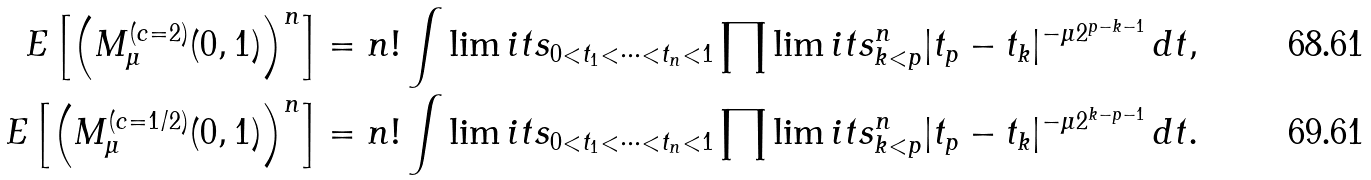<formula> <loc_0><loc_0><loc_500><loc_500>{ E } \left [ \left ( M _ { \mu } ^ { ( c = 2 ) } ( 0 , 1 ) \right ) ^ { n } \right ] & = n ! \int \lim i t s _ { 0 < t _ { 1 } < \cdots < t _ { n } < 1 } \prod \lim i t s _ { k < p } ^ { n } | t _ { p } - t _ { k } | ^ { - \mu 2 ^ { p - k - 1 } } \, d t , \\ { E } \left [ \left ( M _ { \mu } ^ { ( c = 1 / 2 ) } ( 0 , 1 ) \right ) ^ { n } \right ] & = n ! \int \lim i t s _ { 0 < t _ { 1 } < \cdots < t _ { n } < 1 } \prod \lim i t s _ { k < p } ^ { n } | t _ { p } - t _ { k } | ^ { - \mu 2 ^ { k - p - 1 } } \, d t .</formula> 